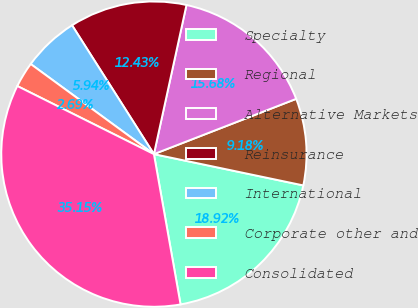Convert chart to OTSL. <chart><loc_0><loc_0><loc_500><loc_500><pie_chart><fcel>Specialty<fcel>Regional<fcel>Alternative Markets<fcel>Reinsurance<fcel>International<fcel>Corporate other and<fcel>Consolidated<nl><fcel>18.92%<fcel>9.18%<fcel>15.68%<fcel>12.43%<fcel>5.94%<fcel>2.69%<fcel>35.15%<nl></chart> 